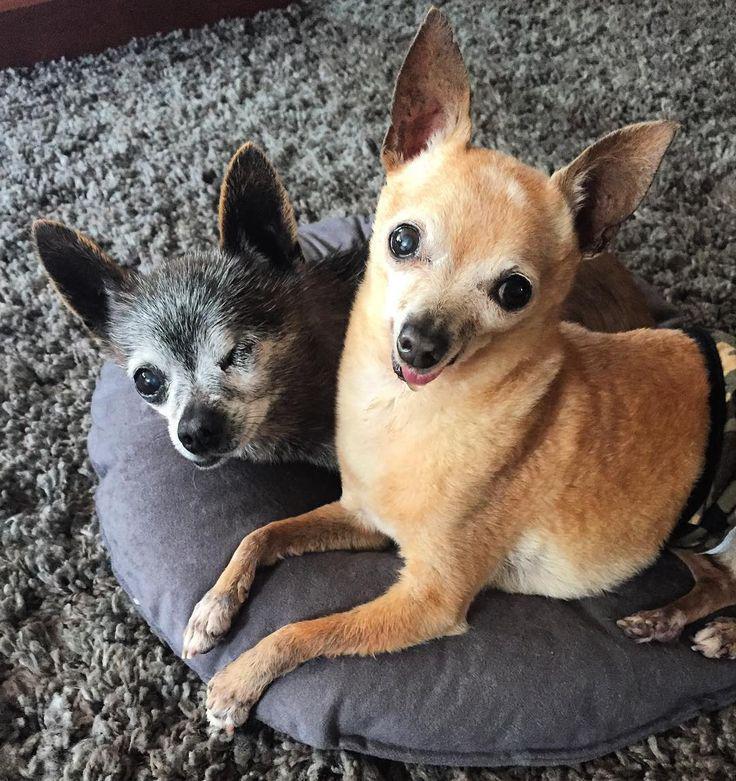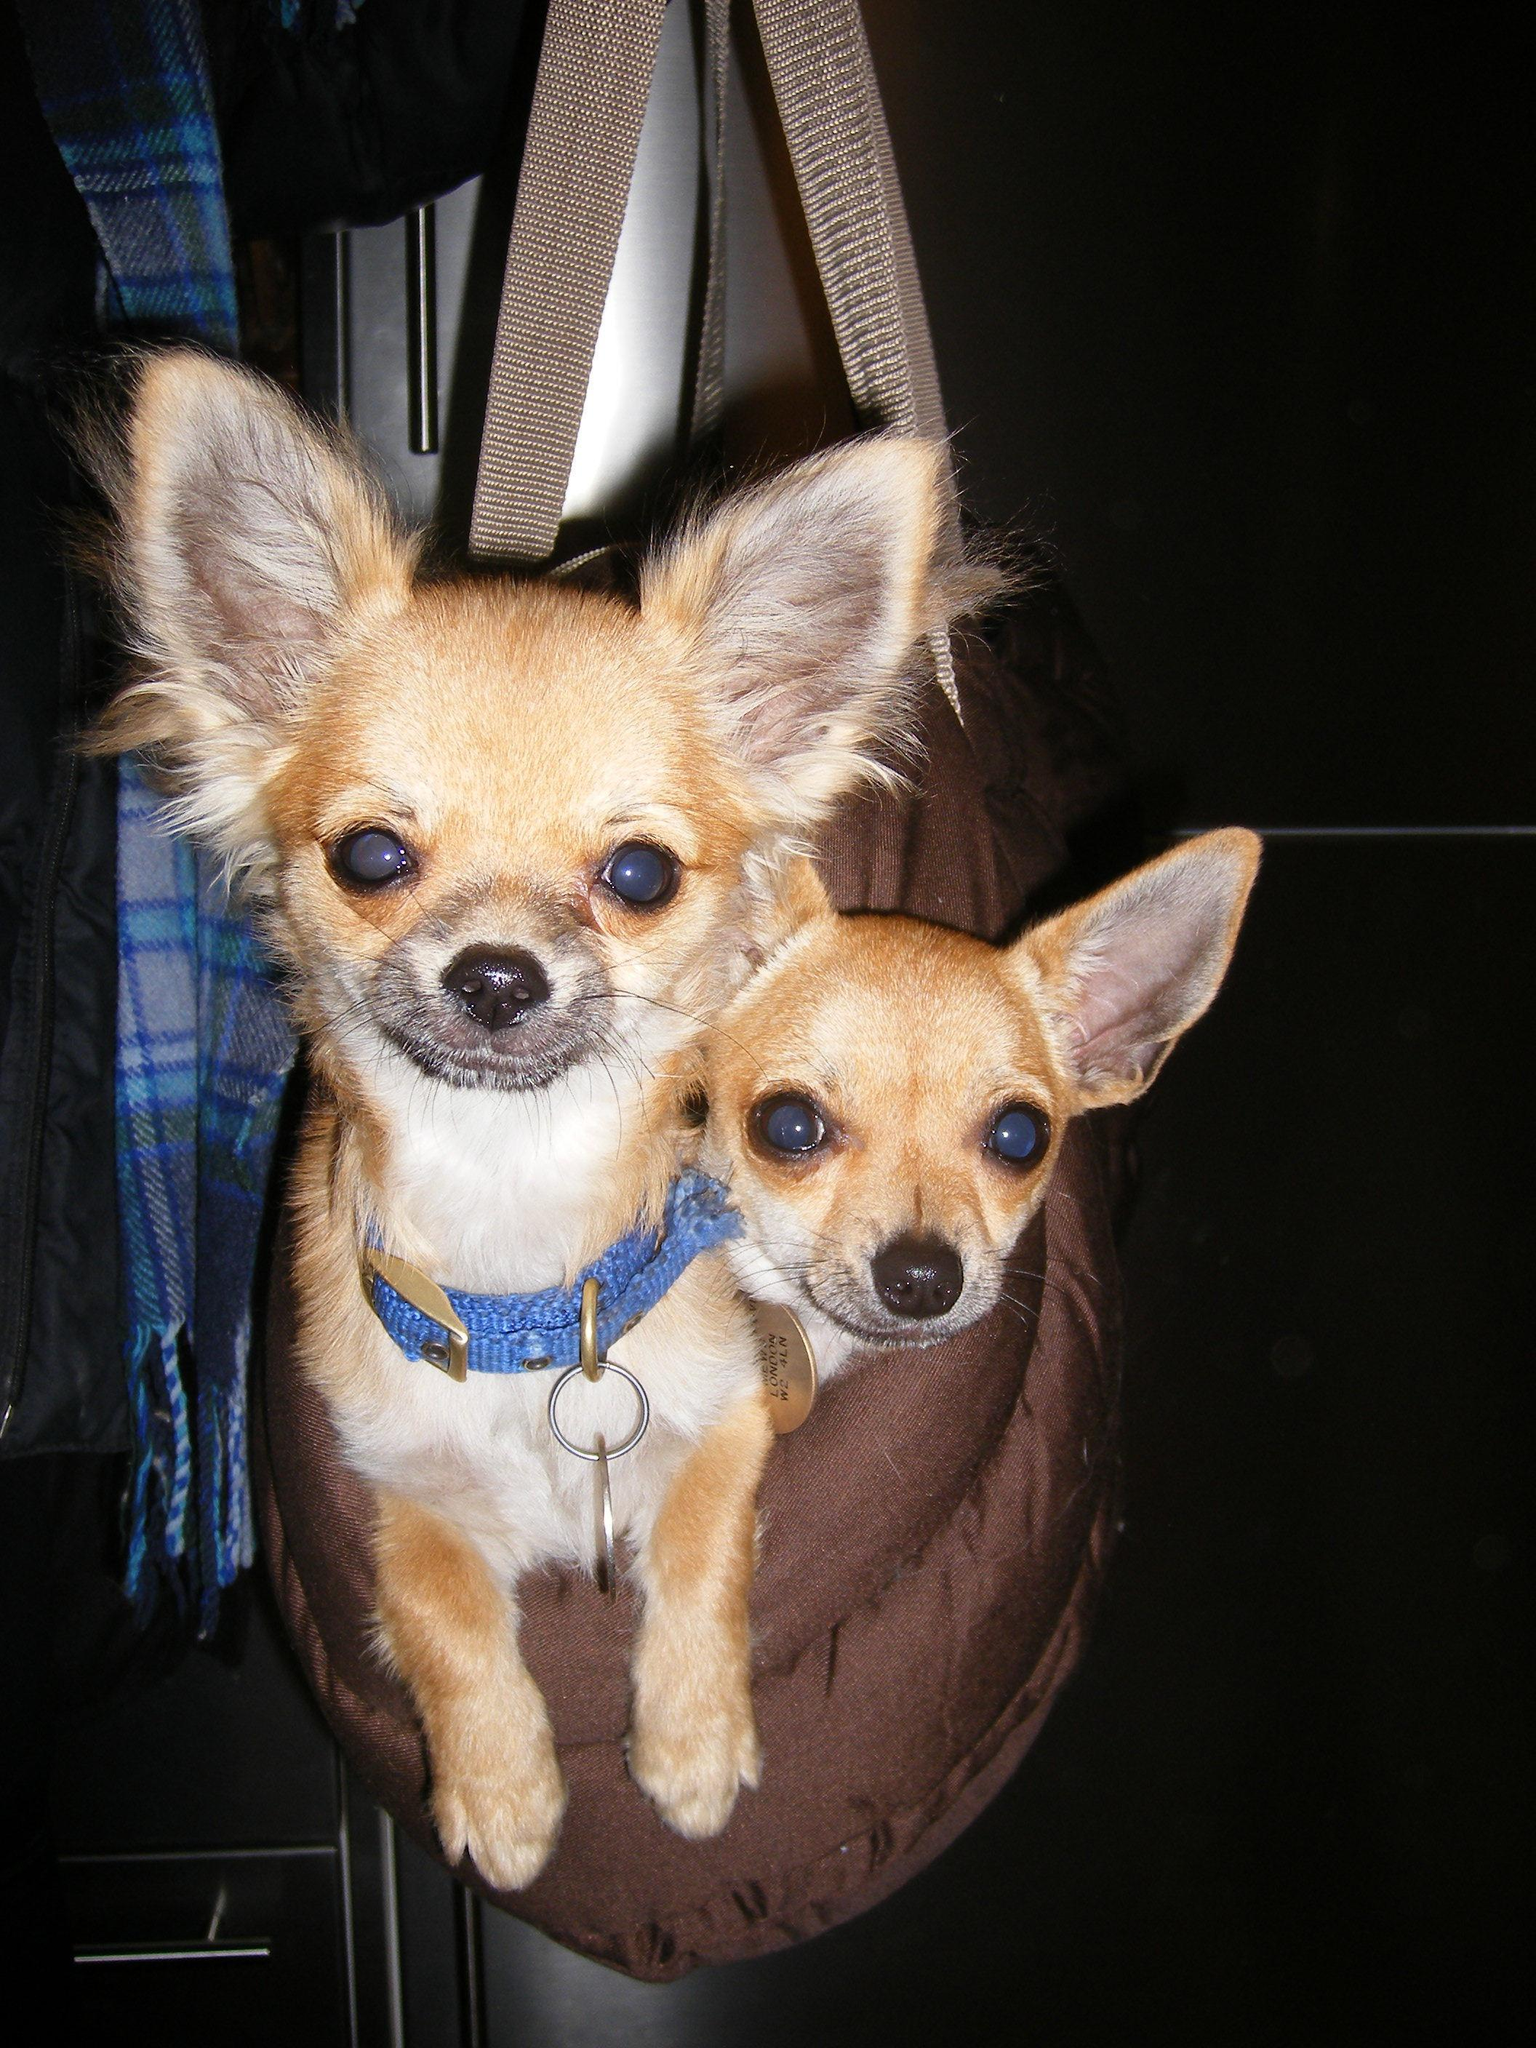The first image is the image on the left, the second image is the image on the right. Assess this claim about the two images: "An image shows two tan dogs with heads side-by-side and erect ears, and one is wearing a bright blue collar.". Correct or not? Answer yes or no. Yes. The first image is the image on the left, the second image is the image on the right. For the images shown, is this caption "One of the dogs is wearing a pink collar." true? Answer yes or no. No. 